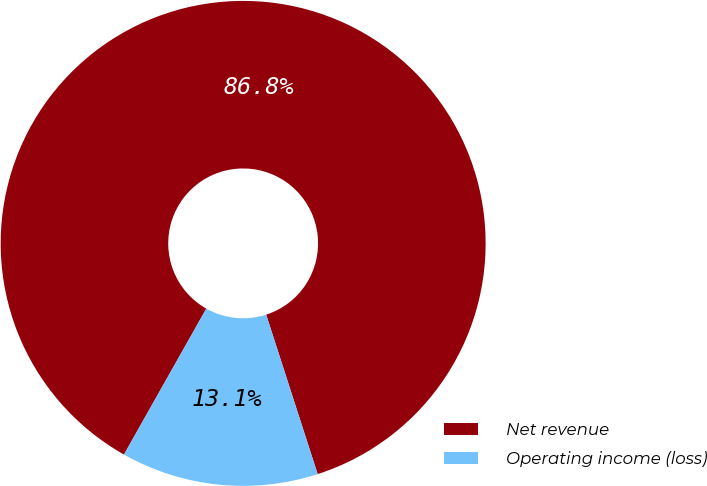Convert chart to OTSL. <chart><loc_0><loc_0><loc_500><loc_500><pie_chart><fcel>Net revenue<fcel>Operating income (loss)<nl><fcel>86.85%<fcel>13.15%<nl></chart> 